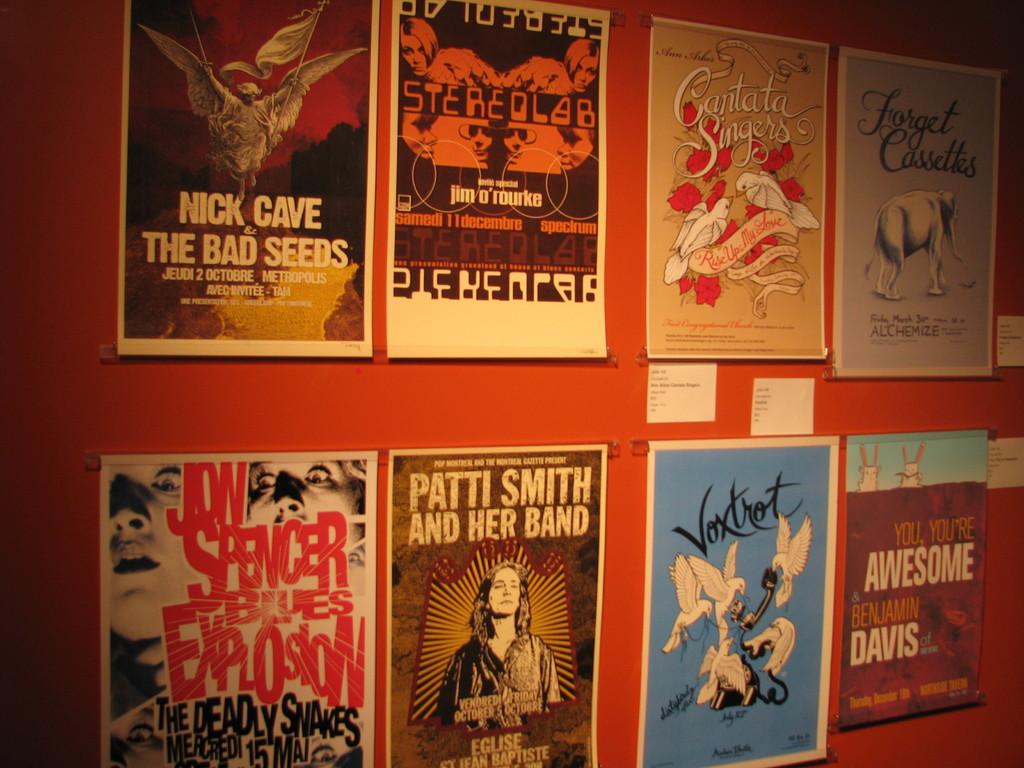Nick cave and the who?
Offer a very short reply. The bad seeds. 